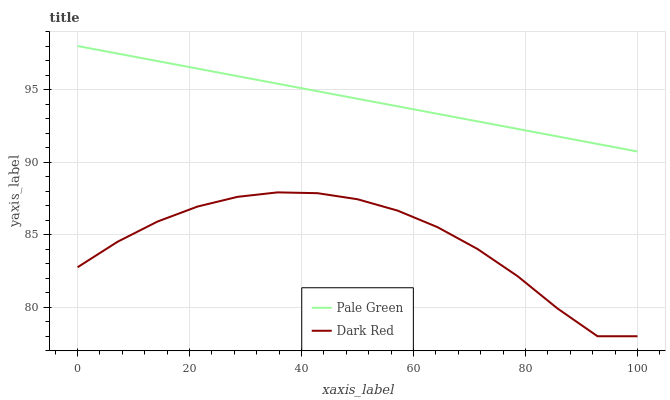Does Dark Red have the minimum area under the curve?
Answer yes or no. Yes. Does Pale Green have the maximum area under the curve?
Answer yes or no. Yes. Does Pale Green have the minimum area under the curve?
Answer yes or no. No. Is Pale Green the smoothest?
Answer yes or no. Yes. Is Dark Red the roughest?
Answer yes or no. Yes. Is Pale Green the roughest?
Answer yes or no. No. Does Dark Red have the lowest value?
Answer yes or no. Yes. Does Pale Green have the lowest value?
Answer yes or no. No. Does Pale Green have the highest value?
Answer yes or no. Yes. Is Dark Red less than Pale Green?
Answer yes or no. Yes. Is Pale Green greater than Dark Red?
Answer yes or no. Yes. Does Dark Red intersect Pale Green?
Answer yes or no. No. 